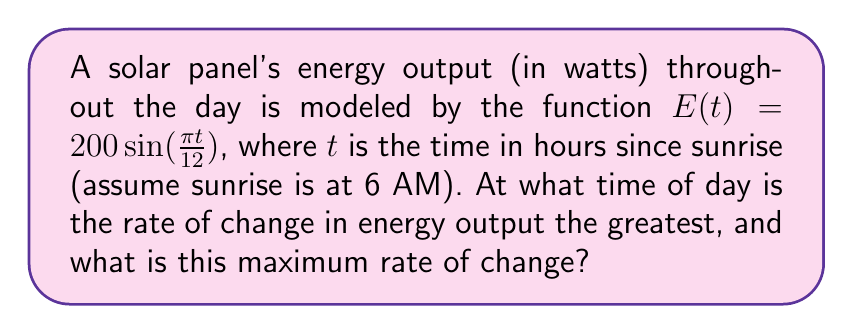Help me with this question. To solve this problem, we need to follow these steps:

1) First, we need to find the derivative of $E(t)$ with respect to $t$. This will give us the rate of change of energy output.

   $$\frac{dE}{dt} = 200 \cdot \frac{\pi}{12} \cos(\frac{\pi t}{12})$$

2) To find the maximum rate of change, we need to find where the second derivative equals zero or doesn't exist.

   $$\frac{d^2E}{dt^2} = 200 \cdot (\frac{\pi}{12})^2 \cdot (-\sin(\frac{\pi t}{12}))$$

3) Set this equal to zero:

   $$200 \cdot (\frac{\pi}{12})^2 \cdot (-\sin(\frac{\pi t}{12})) = 0$$

4) Solve for $t$:

   $$\sin(\frac{\pi t}{12}) = 0$$
   $$\frac{\pi t}{12} = 0, \pi, 2\pi, ...$$
   $$t = 0, 12, 24, ...$$

5) The solutions within our day are $t = 0$ and $t = 12$.

6) To determine which gives the maximum, we can plug these values into our first derivative:

   At $t = 0$: $\frac{dE}{dt} = 200 \cdot \frac{\pi}{12} \cos(0) = 200 \cdot \frac{\pi}{12} \approx 52.36$
   At $t = 12$: $\frac{dE}{dt} = 200 \cdot \frac{\pi}{12} \cos(\pi) = -200 \cdot \frac{\pi}{12} \approx -52.36$

7) The maximum rate of change occurs at $t = 0$, which corresponds to 6 AM (sunrise).

8) The maximum rate of change is $200 \cdot \frac{\pi}{12} \approx 52.36$ watts per hour.
Answer: 6 AM; $52.36$ W/h 